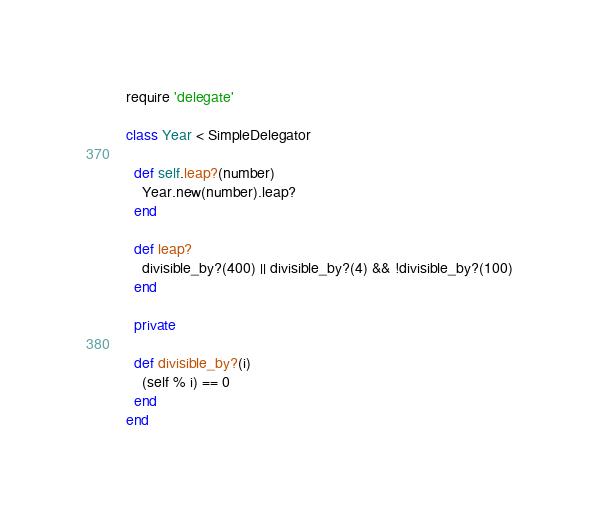Convert code to text. <code><loc_0><loc_0><loc_500><loc_500><_Ruby_>require 'delegate'

class Year < SimpleDelegator

  def self.leap?(number)
    Year.new(number).leap?
  end

  def leap?
    divisible_by?(400) || divisible_by?(4) && !divisible_by?(100)
  end

  private

  def divisible_by?(i)
    (self % i) == 0
  end
end

</code> 